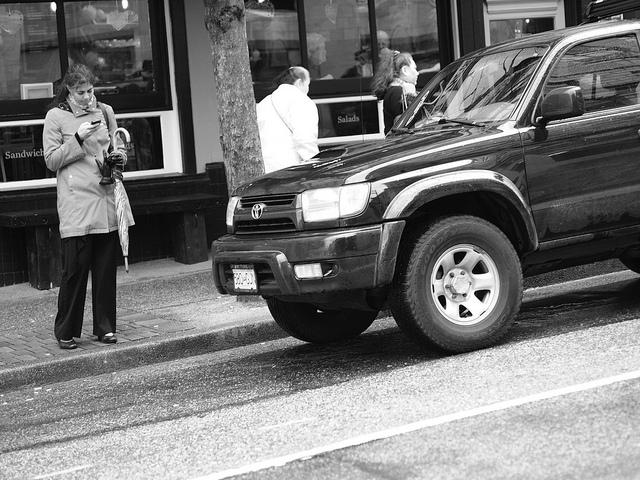Which automotive manufacturer made the jeep? toyota 